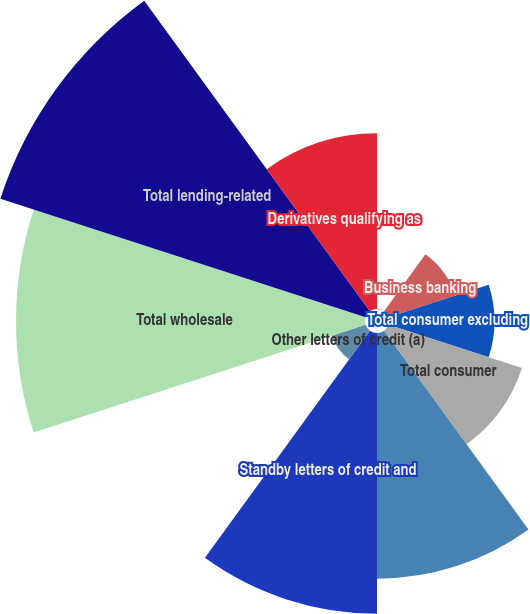Convert chart to OTSL. <chart><loc_0><loc_0><loc_500><loc_500><pie_chart><fcel>Auto<fcel>Business banking<fcel>Total consumer excluding<fcel>Total consumer<fcel>Other unfunded commitments to<fcel>Standby letters of credit and<fcel>Other letters of credit (a)<fcel>Total wholesale<fcel>Total lending-related<fcel>Derivatives qualifying as<nl><fcel>0.01%<fcel>3.94%<fcel>5.9%<fcel>7.86%<fcel>13.75%<fcel>15.71%<fcel>1.98%<fcel>19.53%<fcel>21.49%<fcel>9.83%<nl></chart> 